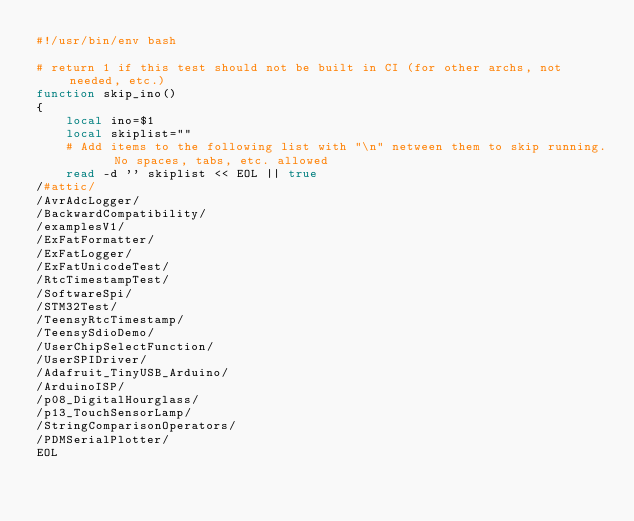<code> <loc_0><loc_0><loc_500><loc_500><_Bash_>#!/usr/bin/env bash

# return 1 if this test should not be built in CI (for other archs, not needed, etc.)
function skip_ino()
{
    local ino=$1
    local skiplist=""
    # Add items to the following list with "\n" netween them to skip running.  No spaces, tabs, etc. allowed
    read -d '' skiplist << EOL || true
/#attic/
/AvrAdcLogger/
/BackwardCompatibility/
/examplesV1/
/ExFatFormatter/
/ExFatLogger/
/ExFatUnicodeTest/
/RtcTimestampTest/
/SoftwareSpi/
/STM32Test/
/TeensyRtcTimestamp/
/TeensySdioDemo/
/UserChipSelectFunction/
/UserSPIDriver/
/Adafruit_TinyUSB_Arduino/
/ArduinoISP/
/p08_DigitalHourglass/
/p13_TouchSensorLamp/
/StringComparisonOperators/
/PDMSerialPlotter/
EOL</code> 